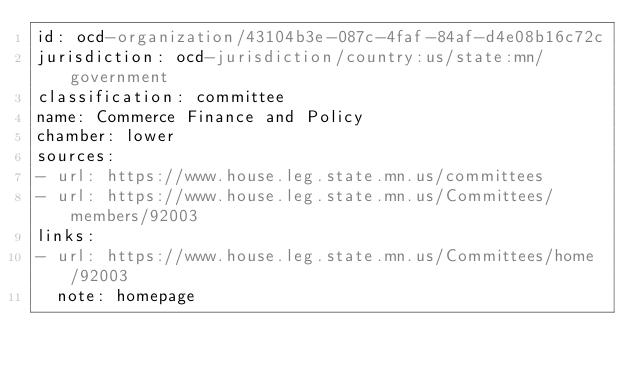Convert code to text. <code><loc_0><loc_0><loc_500><loc_500><_YAML_>id: ocd-organization/43104b3e-087c-4faf-84af-d4e08b16c72c
jurisdiction: ocd-jurisdiction/country:us/state:mn/government
classification: committee
name: Commerce Finance and Policy
chamber: lower
sources:
- url: https://www.house.leg.state.mn.us/committees
- url: https://www.house.leg.state.mn.us/Committees/members/92003
links:
- url: https://www.house.leg.state.mn.us/Committees/home/92003
  note: homepage</code> 